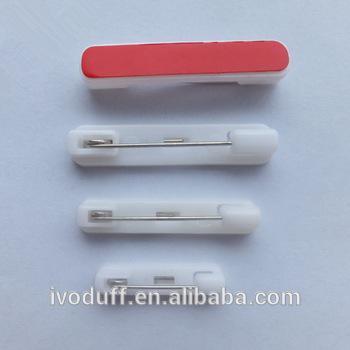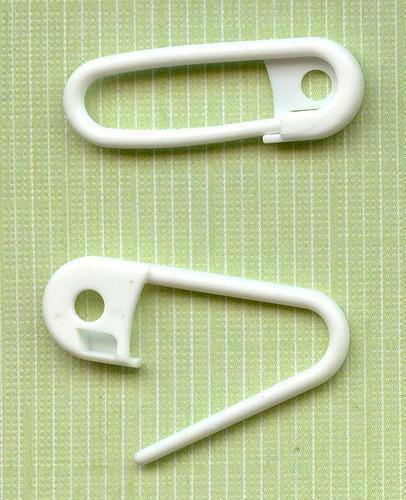The first image is the image on the left, the second image is the image on the right. Given the left and right images, does the statement "At least one safety pin is purple." hold true? Answer yes or no. No. 